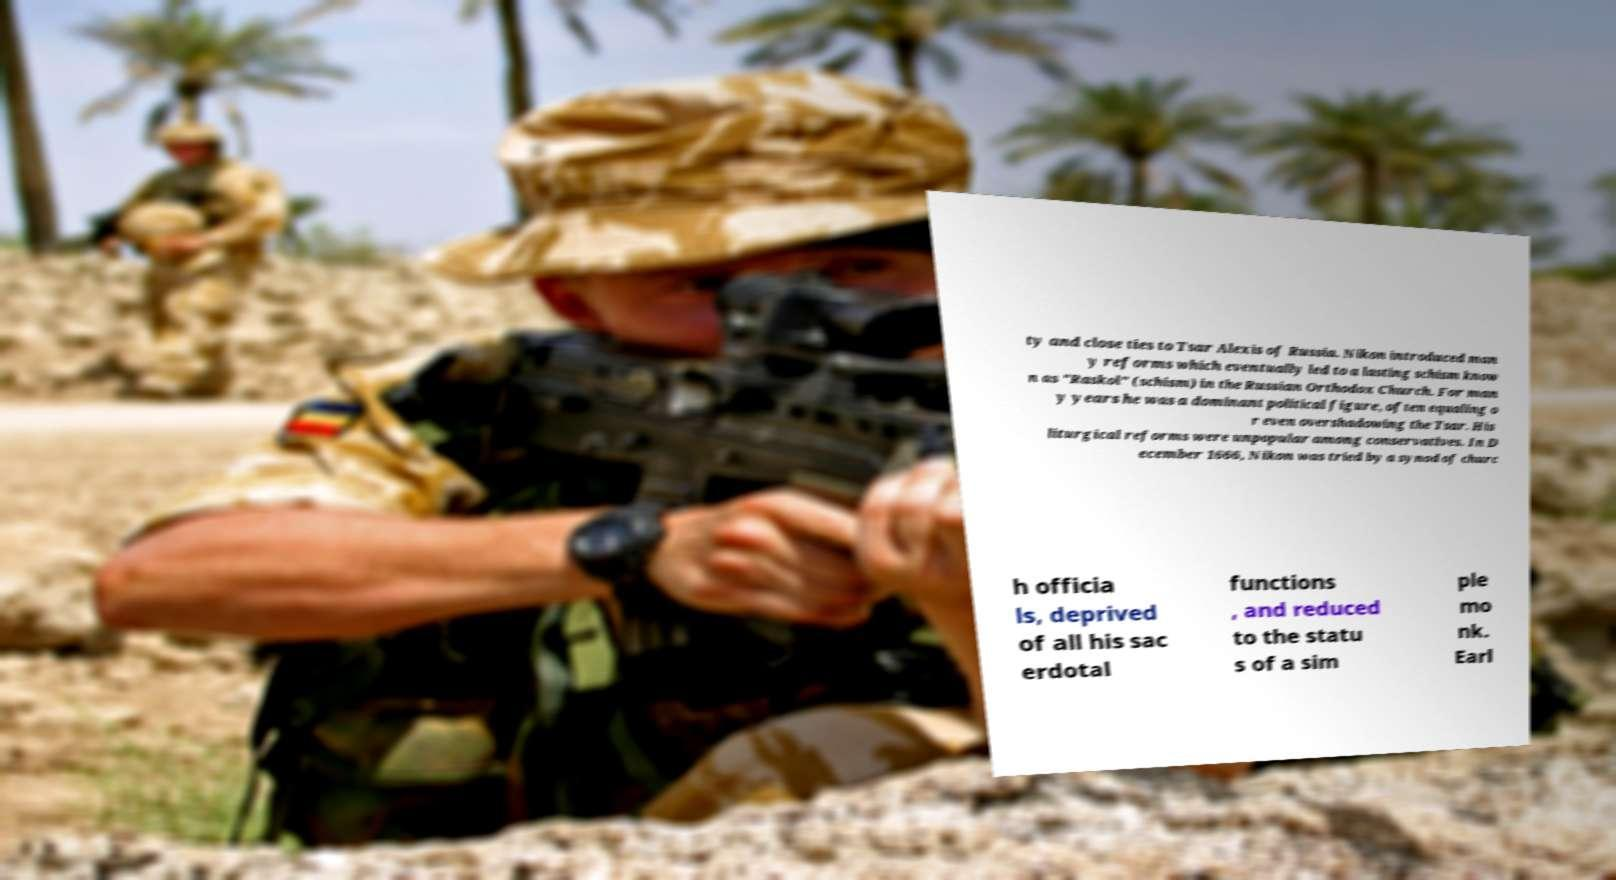What messages or text are displayed in this image? I need them in a readable, typed format. ty and close ties to Tsar Alexis of Russia. Nikon introduced man y reforms which eventually led to a lasting schism know n as "Raskol" (schism) in the Russian Orthodox Church. For man y years he was a dominant political figure, often equaling o r even overshadowing the Tsar. His liturgical reforms were unpopular among conservatives. In D ecember 1666, Nikon was tried by a synod of churc h officia ls, deprived of all his sac erdotal functions , and reduced to the statu s of a sim ple mo nk. Earl 